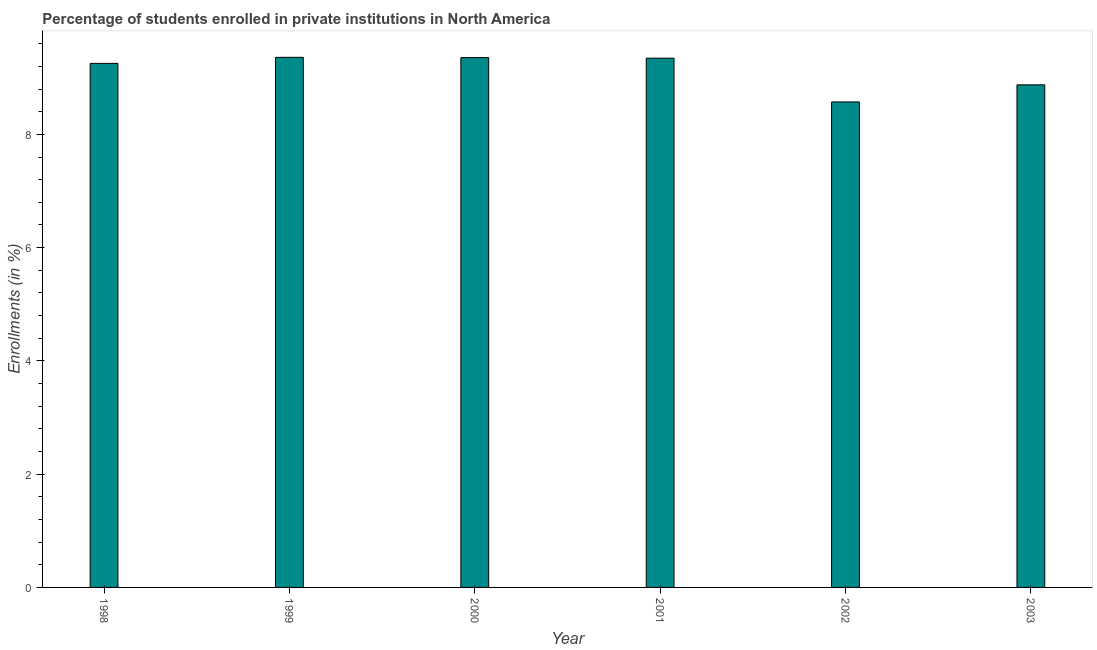What is the title of the graph?
Give a very brief answer. Percentage of students enrolled in private institutions in North America. What is the label or title of the X-axis?
Offer a very short reply. Year. What is the label or title of the Y-axis?
Offer a terse response. Enrollments (in %). What is the enrollments in private institutions in 1998?
Offer a very short reply. 9.25. Across all years, what is the maximum enrollments in private institutions?
Ensure brevity in your answer.  9.36. Across all years, what is the minimum enrollments in private institutions?
Your response must be concise. 8.57. In which year was the enrollments in private institutions minimum?
Provide a succinct answer. 2002. What is the sum of the enrollments in private institutions?
Ensure brevity in your answer.  54.76. What is the difference between the enrollments in private institutions in 1998 and 2002?
Provide a succinct answer. 0.68. What is the average enrollments in private institutions per year?
Your response must be concise. 9.13. What is the median enrollments in private institutions?
Provide a short and direct response. 9.3. In how many years, is the enrollments in private institutions greater than 0.4 %?
Your response must be concise. 6. What is the ratio of the enrollments in private institutions in 1998 to that in 2002?
Give a very brief answer. 1.08. Is the difference between the enrollments in private institutions in 1999 and 2001 greater than the difference between any two years?
Offer a very short reply. No. What is the difference between the highest and the second highest enrollments in private institutions?
Offer a terse response. 0.01. What is the difference between the highest and the lowest enrollments in private institutions?
Your answer should be compact. 0.79. In how many years, is the enrollments in private institutions greater than the average enrollments in private institutions taken over all years?
Offer a terse response. 4. How many bars are there?
Offer a very short reply. 6. Are all the bars in the graph horizontal?
Offer a very short reply. No. How many years are there in the graph?
Provide a short and direct response. 6. Are the values on the major ticks of Y-axis written in scientific E-notation?
Ensure brevity in your answer.  No. What is the Enrollments (in %) in 1998?
Your answer should be compact. 9.25. What is the Enrollments (in %) of 1999?
Your answer should be very brief. 9.36. What is the Enrollments (in %) in 2000?
Your response must be concise. 9.36. What is the Enrollments (in %) of 2001?
Keep it short and to the point. 9.35. What is the Enrollments (in %) in 2002?
Make the answer very short. 8.57. What is the Enrollments (in %) of 2003?
Ensure brevity in your answer.  8.87. What is the difference between the Enrollments (in %) in 1998 and 1999?
Provide a short and direct response. -0.11. What is the difference between the Enrollments (in %) in 1998 and 2000?
Ensure brevity in your answer.  -0.1. What is the difference between the Enrollments (in %) in 1998 and 2001?
Provide a succinct answer. -0.09. What is the difference between the Enrollments (in %) in 1998 and 2002?
Offer a terse response. 0.68. What is the difference between the Enrollments (in %) in 1998 and 2003?
Your answer should be very brief. 0.38. What is the difference between the Enrollments (in %) in 1999 and 2000?
Give a very brief answer. 0. What is the difference between the Enrollments (in %) in 1999 and 2001?
Give a very brief answer. 0.01. What is the difference between the Enrollments (in %) in 1999 and 2002?
Give a very brief answer. 0.79. What is the difference between the Enrollments (in %) in 1999 and 2003?
Provide a succinct answer. 0.49. What is the difference between the Enrollments (in %) in 2000 and 2001?
Keep it short and to the point. 0.01. What is the difference between the Enrollments (in %) in 2000 and 2002?
Make the answer very short. 0.78. What is the difference between the Enrollments (in %) in 2000 and 2003?
Your answer should be compact. 0.48. What is the difference between the Enrollments (in %) in 2001 and 2002?
Provide a short and direct response. 0.77. What is the difference between the Enrollments (in %) in 2001 and 2003?
Offer a terse response. 0.47. What is the difference between the Enrollments (in %) in 2002 and 2003?
Give a very brief answer. -0.3. What is the ratio of the Enrollments (in %) in 1998 to that in 2002?
Make the answer very short. 1.08. What is the ratio of the Enrollments (in %) in 1998 to that in 2003?
Offer a terse response. 1.04. What is the ratio of the Enrollments (in %) in 1999 to that in 2002?
Offer a very short reply. 1.09. What is the ratio of the Enrollments (in %) in 1999 to that in 2003?
Offer a very short reply. 1.05. What is the ratio of the Enrollments (in %) in 2000 to that in 2002?
Your answer should be compact. 1.09. What is the ratio of the Enrollments (in %) in 2000 to that in 2003?
Make the answer very short. 1.05. What is the ratio of the Enrollments (in %) in 2001 to that in 2002?
Offer a terse response. 1.09. What is the ratio of the Enrollments (in %) in 2001 to that in 2003?
Offer a very short reply. 1.05. What is the ratio of the Enrollments (in %) in 2002 to that in 2003?
Ensure brevity in your answer.  0.97. 